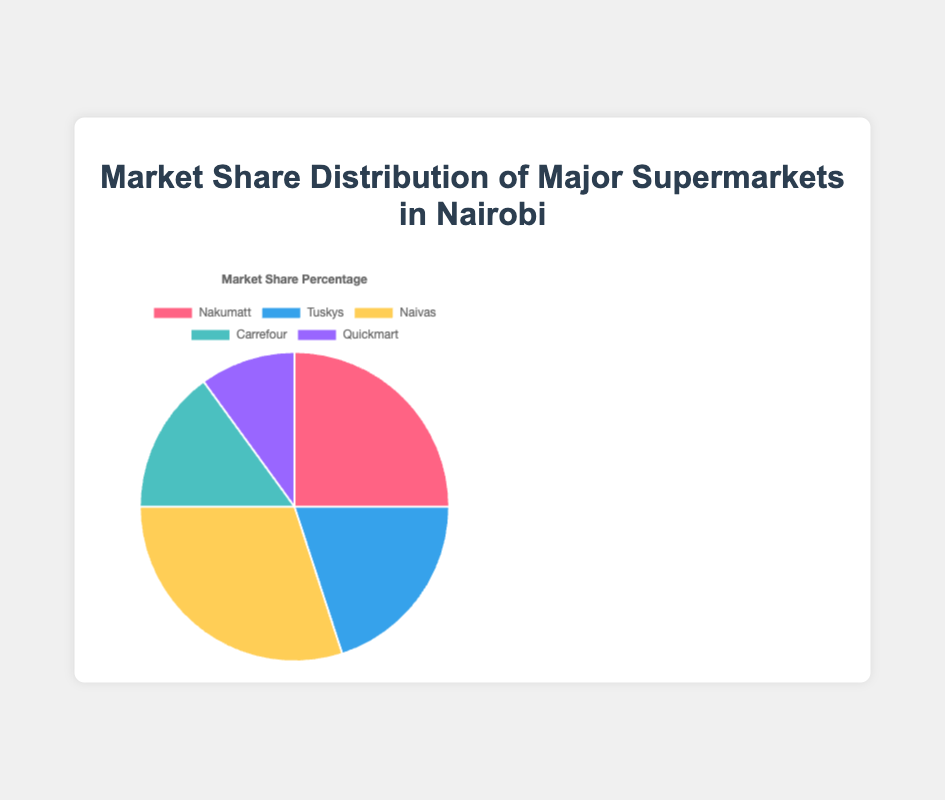Which supermarket has the largest market share? Naivas has the largest market share at 30%, which is visually the most significant segment in the pie chart. Just look for the largest slice in the figure.
Answer: Naivas What is the total market share of Nakumatt and Carrefour combined? Add the market share percentages of Nakumatt (25%) and Carrefour (15%). 25% + 15% = 40%
Answer: 40% How much greater is Naivas' market share compared to Quickmart's? Subtract Quickmart's market share (10%) from Naivas' market share (30%). 30% - 10% = 20%
Answer: 20% Which supermarkets have a market share greater than 20%? Look at the percentages in the pie chart. Nakumatt (25%) and Naivas (30%) both have market shares greater than 20%.
Answer: Nakumatt, Naivas What is the average market share of all the supermarkets? Sum all market share percentages and divide by the number of supermarkets. (25% + 20% + 30% + 15% + 10%) / 5 = 100% / 5 = 20%
Answer: 20% Rank the supermarkets from largest to smallest market share. Order the supermarkets based on their market share percentages from the pie chart: Naivas (30%), Nakumatt (25%), Tuskys (20%), Carrefour (15%), Quickmart (10%)
Answer: Naivas, Nakumatt, Tuskys, Carrefour, Quickmart Which supermarket's market share is visualized in blue? Identify the segment in blue color which corresponds to Tuskys. The color blue is associated with Tuskys' 20% market share.
Answer: Tuskys How much smaller is Carrefour's market share compared to Nakumatt's? Subtract Carrefour's market share (15%) from Nakumatt's market share (25%). 25% - 15% = 10%
Answer: 10% What is the sum of the market shares of Carrefour and Quickmart? Add the market share percentages of Carrefour (15%) and Quickmart (10%). 15% + 10% = 25%
Answer: 25% Is Tuskys' market share greater than Carrefour's? Compare Tuskys' market share (20%) to Carrefour's market share (15%). Yes, 20% is greater than 15%.
Answer: Yes 